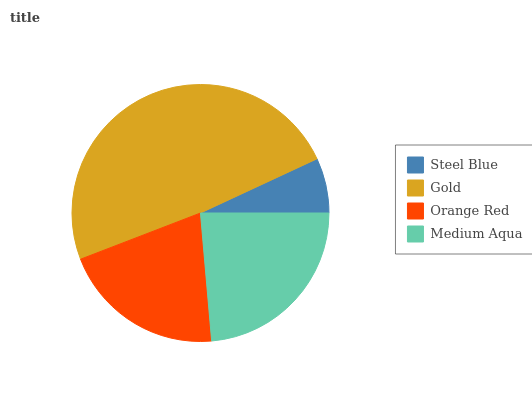Is Steel Blue the minimum?
Answer yes or no. Yes. Is Gold the maximum?
Answer yes or no. Yes. Is Orange Red the minimum?
Answer yes or no. No. Is Orange Red the maximum?
Answer yes or no. No. Is Gold greater than Orange Red?
Answer yes or no. Yes. Is Orange Red less than Gold?
Answer yes or no. Yes. Is Orange Red greater than Gold?
Answer yes or no. No. Is Gold less than Orange Red?
Answer yes or no. No. Is Medium Aqua the high median?
Answer yes or no. Yes. Is Orange Red the low median?
Answer yes or no. Yes. Is Steel Blue the high median?
Answer yes or no. No. Is Steel Blue the low median?
Answer yes or no. No. 